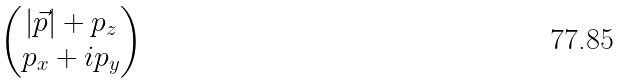<formula> <loc_0><loc_0><loc_500><loc_500>\begin{pmatrix} | \vec { p } | + p _ { z } \\ p _ { x } + i p _ { y } \end{pmatrix}</formula> 